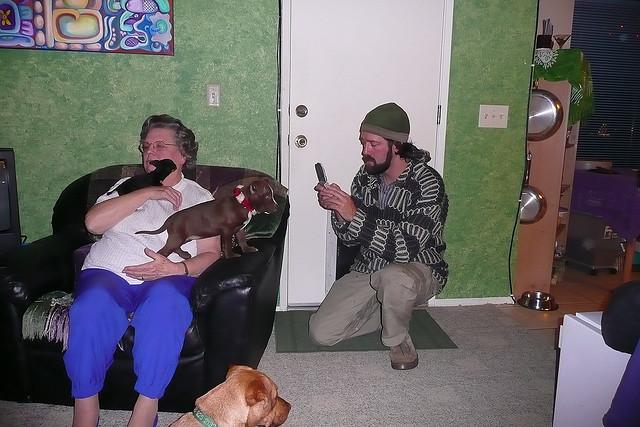How many dogs are in the  picture?
Keep it brief. 3. How many light switches are there?
Keep it brief. 4. How many pots are on the wall?
Short answer required. 2. 